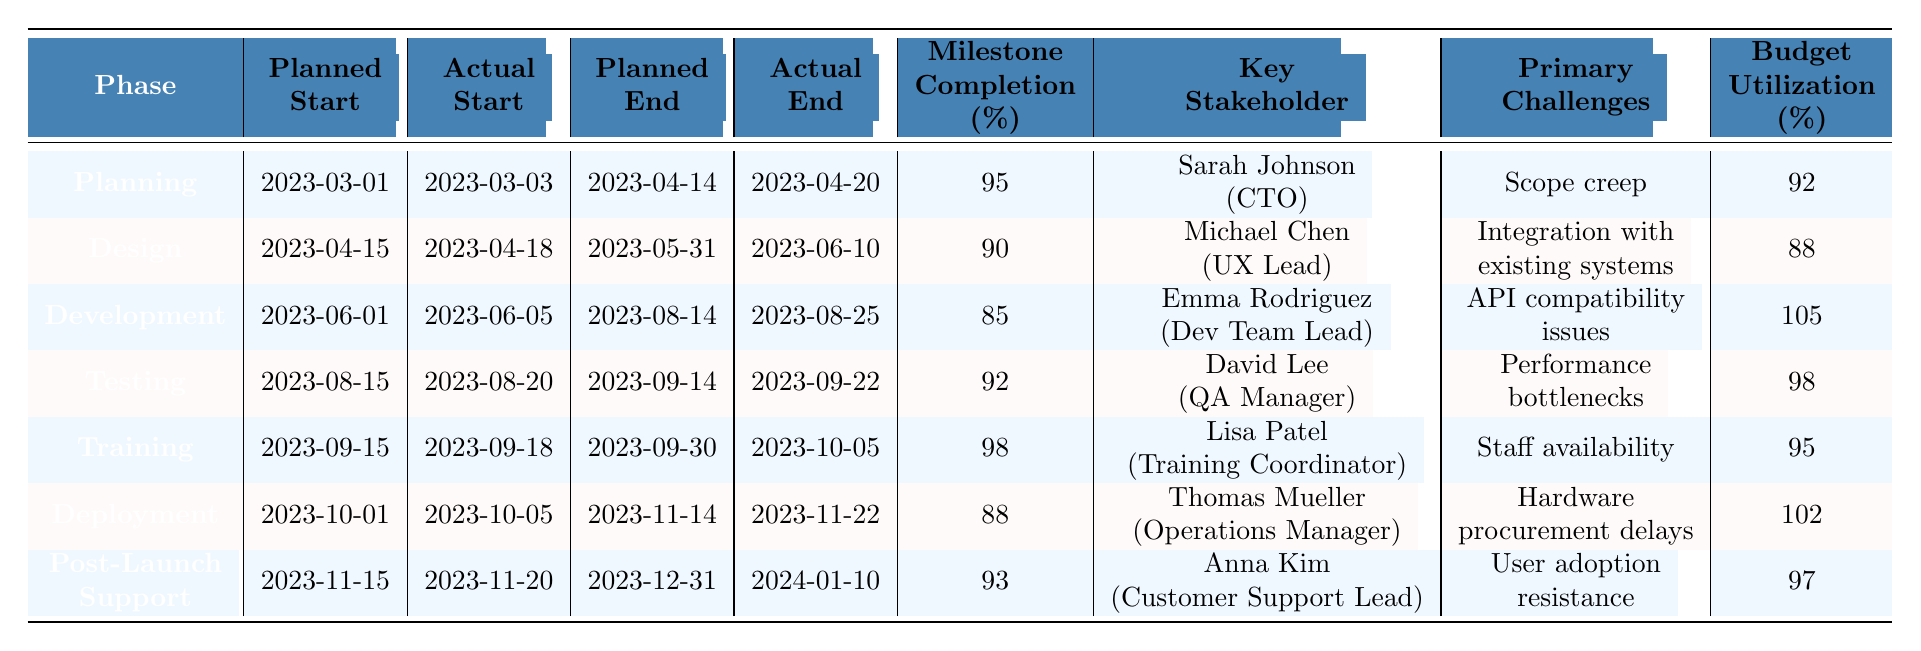What is the Milestone Completion Rate for the Design phase? The table shows that the Milestone Completion Rate for the Design phase is listed directly under the corresponding row, which indicates it is 90%.
Answer: 90 Which phase had the highest Budget Utilization? By reviewing the Budget Utilization column, I see that the Development phase has a utilization rate of 105%, which is the highest among all listed phases.
Answer: 105 Did the Actual End Date for Training occur later than its Planned End Date? The Planned End Date for the Training phase is 2023-09-30, and the Actual End Date is 2023-10-05, which is later than the planned date. Therefore, the answer is yes.
Answer: Yes What is the difference in days between the Planned Start Date and Actual Start Date for the Deployment phase? The Planned Start Date for Deployment is 2023-10-01, and the Actual Start Date is 2023-10-05. The difference is 5-1 = 4 days (2023-10-05 minus 2023-10-01).
Answer: 4 days Which phase had the least number of total days between the Planned Start and Planned End dates? I calculate the duration for each phase by taking the difference between the Planned End Date and Planned Start Date. The Planning phase has 44 days (from 2023-03-01 to 2023-04-14), while the Training phase has only 15 days (from 2023-09-15 to 2023-09-30). Thus, the Training phase has the least duration.
Answer: Training What percentage of phases experienced delays in their start dates? I check how many phases had Actual Start Dates later than Planned Start Dates. Only the Design, Development, Testing, and Deployment phases experienced delays, which is 4 out of 7 phases. The percentage is (4/7) * 100 = approximately 57.14%.
Answer: Approximately 57.14% Which Key Stakeholder's phase had the second highest Milestone Completion Rate? I sort the Milestone Completion Rates and find that the highest is for Training at 98%, and the second highest is for Testing at 92%. The Key Stakeholder for Testing is David Lee (QA Manager).
Answer: David Lee (QA Manager) Is the Budget Utilization for the Post-Launch Support phase above or below 100%? Looking at the Budget Utilization for the Post-Launch Support phase, I see it is 97%, which is below 100%. Therefore, the answer is below.
Answer: Below What is the average Milestone Completion Rate across all phases? I sum up all the Milestone Completion Rates: 95 + 90 + 85 + 92 + 98 + 88 + 93 = 621. There are 7 phases, so I calculate the average as 621/7 = approximately 88.71%.
Answer: Approximately 88.71% 